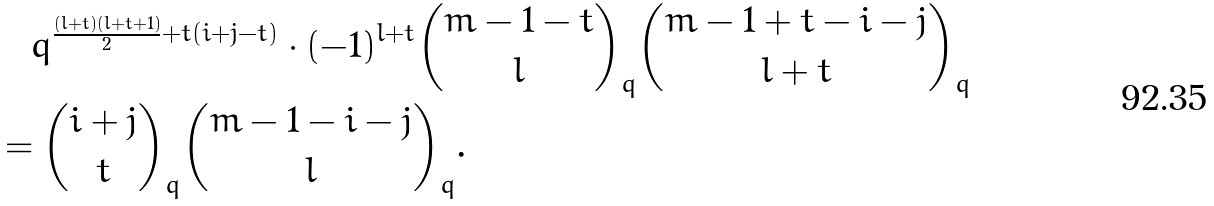Convert formula to latex. <formula><loc_0><loc_0><loc_500><loc_500>& \quad q ^ { \frac { ( l + t ) ( l + t + 1 ) } { 2 } + t ( i + j - t ) } \cdot ( - 1 ) ^ { l + t } \binom { m - 1 - t } { l } _ { q } \binom { m - 1 + t - i - j } { l + t } _ { q } \\ & = \binom { i + j } { t } _ { q } \binom { m - 1 - i - j } { l } _ { q } .</formula> 